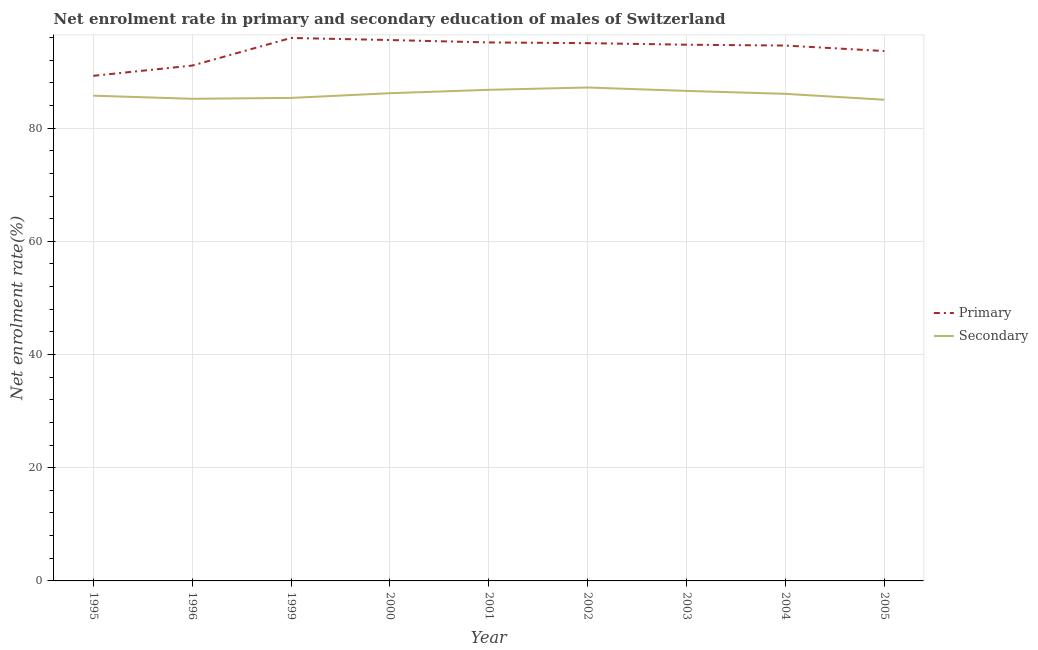What is the enrollment rate in primary education in 2004?
Keep it short and to the point. 94.58. Across all years, what is the maximum enrollment rate in primary education?
Offer a very short reply. 95.92. Across all years, what is the minimum enrollment rate in secondary education?
Ensure brevity in your answer.  85.01. In which year was the enrollment rate in primary education maximum?
Offer a very short reply. 1999. In which year was the enrollment rate in secondary education minimum?
Provide a short and direct response. 2005. What is the total enrollment rate in secondary education in the graph?
Your answer should be very brief. 773.93. What is the difference between the enrollment rate in primary education in 1996 and that in 2002?
Give a very brief answer. -3.96. What is the difference between the enrollment rate in secondary education in 2003 and the enrollment rate in primary education in 2001?
Your answer should be compact. -8.56. What is the average enrollment rate in primary education per year?
Make the answer very short. 93.86. In the year 2005, what is the difference between the enrollment rate in primary education and enrollment rate in secondary education?
Provide a succinct answer. 8.6. What is the ratio of the enrollment rate in secondary education in 1999 to that in 2000?
Your answer should be compact. 0.99. Is the enrollment rate in secondary education in 1996 less than that in 2000?
Make the answer very short. Yes. What is the difference between the highest and the second highest enrollment rate in secondary education?
Make the answer very short. 0.41. What is the difference between the highest and the lowest enrollment rate in primary education?
Your answer should be compact. 6.69. Is the enrollment rate in secondary education strictly greater than the enrollment rate in primary education over the years?
Offer a very short reply. No. Is the enrollment rate in secondary education strictly less than the enrollment rate in primary education over the years?
Offer a very short reply. Yes. Are the values on the major ticks of Y-axis written in scientific E-notation?
Provide a succinct answer. No. Does the graph contain any zero values?
Offer a very short reply. No. How many legend labels are there?
Keep it short and to the point. 2. What is the title of the graph?
Give a very brief answer. Net enrolment rate in primary and secondary education of males of Switzerland. What is the label or title of the Y-axis?
Your answer should be very brief. Net enrolment rate(%). What is the Net enrolment rate(%) in Primary in 1995?
Ensure brevity in your answer.  89.23. What is the Net enrolment rate(%) of Secondary in 1995?
Offer a terse response. 85.72. What is the Net enrolment rate(%) of Primary in 1996?
Your answer should be compact. 91.04. What is the Net enrolment rate(%) in Secondary in 1996?
Keep it short and to the point. 85.17. What is the Net enrolment rate(%) of Primary in 1999?
Keep it short and to the point. 95.92. What is the Net enrolment rate(%) in Secondary in 1999?
Provide a short and direct response. 85.33. What is the Net enrolment rate(%) in Primary in 2000?
Provide a short and direct response. 95.55. What is the Net enrolment rate(%) in Secondary in 2000?
Your answer should be compact. 86.16. What is the Net enrolment rate(%) in Primary in 2001?
Make the answer very short. 95.13. What is the Net enrolment rate(%) in Secondary in 2001?
Make the answer very short. 86.76. What is the Net enrolment rate(%) in Primary in 2002?
Give a very brief answer. 95. What is the Net enrolment rate(%) of Secondary in 2002?
Your answer should be compact. 87.17. What is the Net enrolment rate(%) in Primary in 2003?
Your answer should be compact. 94.73. What is the Net enrolment rate(%) in Secondary in 2003?
Make the answer very short. 86.57. What is the Net enrolment rate(%) in Primary in 2004?
Keep it short and to the point. 94.58. What is the Net enrolment rate(%) of Secondary in 2004?
Offer a terse response. 86.05. What is the Net enrolment rate(%) in Primary in 2005?
Keep it short and to the point. 93.61. What is the Net enrolment rate(%) in Secondary in 2005?
Your answer should be very brief. 85.01. Across all years, what is the maximum Net enrolment rate(%) in Primary?
Your answer should be very brief. 95.92. Across all years, what is the maximum Net enrolment rate(%) in Secondary?
Your response must be concise. 87.17. Across all years, what is the minimum Net enrolment rate(%) in Primary?
Give a very brief answer. 89.23. Across all years, what is the minimum Net enrolment rate(%) of Secondary?
Offer a very short reply. 85.01. What is the total Net enrolment rate(%) of Primary in the graph?
Give a very brief answer. 844.78. What is the total Net enrolment rate(%) in Secondary in the graph?
Keep it short and to the point. 773.93. What is the difference between the Net enrolment rate(%) of Primary in 1995 and that in 1996?
Offer a terse response. -1.81. What is the difference between the Net enrolment rate(%) of Secondary in 1995 and that in 1996?
Give a very brief answer. 0.55. What is the difference between the Net enrolment rate(%) of Primary in 1995 and that in 1999?
Your response must be concise. -6.69. What is the difference between the Net enrolment rate(%) in Secondary in 1995 and that in 1999?
Give a very brief answer. 0.4. What is the difference between the Net enrolment rate(%) of Primary in 1995 and that in 2000?
Keep it short and to the point. -6.32. What is the difference between the Net enrolment rate(%) in Secondary in 1995 and that in 2000?
Keep it short and to the point. -0.43. What is the difference between the Net enrolment rate(%) in Primary in 1995 and that in 2001?
Offer a terse response. -5.9. What is the difference between the Net enrolment rate(%) in Secondary in 1995 and that in 2001?
Offer a terse response. -1.04. What is the difference between the Net enrolment rate(%) in Primary in 1995 and that in 2002?
Provide a succinct answer. -5.77. What is the difference between the Net enrolment rate(%) in Secondary in 1995 and that in 2002?
Ensure brevity in your answer.  -1.44. What is the difference between the Net enrolment rate(%) in Primary in 1995 and that in 2003?
Offer a terse response. -5.5. What is the difference between the Net enrolment rate(%) in Secondary in 1995 and that in 2003?
Provide a short and direct response. -0.84. What is the difference between the Net enrolment rate(%) of Primary in 1995 and that in 2004?
Your answer should be very brief. -5.35. What is the difference between the Net enrolment rate(%) of Secondary in 1995 and that in 2004?
Your answer should be compact. -0.32. What is the difference between the Net enrolment rate(%) of Primary in 1995 and that in 2005?
Provide a succinct answer. -4.38. What is the difference between the Net enrolment rate(%) of Secondary in 1995 and that in 2005?
Ensure brevity in your answer.  0.72. What is the difference between the Net enrolment rate(%) of Primary in 1996 and that in 1999?
Provide a succinct answer. -4.88. What is the difference between the Net enrolment rate(%) of Secondary in 1996 and that in 1999?
Make the answer very short. -0.16. What is the difference between the Net enrolment rate(%) of Primary in 1996 and that in 2000?
Give a very brief answer. -4.51. What is the difference between the Net enrolment rate(%) of Secondary in 1996 and that in 2000?
Make the answer very short. -0.98. What is the difference between the Net enrolment rate(%) in Primary in 1996 and that in 2001?
Provide a succinct answer. -4.09. What is the difference between the Net enrolment rate(%) in Secondary in 1996 and that in 2001?
Provide a short and direct response. -1.59. What is the difference between the Net enrolment rate(%) in Primary in 1996 and that in 2002?
Provide a short and direct response. -3.96. What is the difference between the Net enrolment rate(%) of Secondary in 1996 and that in 2002?
Offer a very short reply. -1.99. What is the difference between the Net enrolment rate(%) in Primary in 1996 and that in 2003?
Keep it short and to the point. -3.69. What is the difference between the Net enrolment rate(%) of Secondary in 1996 and that in 2003?
Ensure brevity in your answer.  -1.39. What is the difference between the Net enrolment rate(%) of Primary in 1996 and that in 2004?
Give a very brief answer. -3.54. What is the difference between the Net enrolment rate(%) of Secondary in 1996 and that in 2004?
Your answer should be compact. -0.88. What is the difference between the Net enrolment rate(%) in Primary in 1996 and that in 2005?
Give a very brief answer. -2.57. What is the difference between the Net enrolment rate(%) in Secondary in 1996 and that in 2005?
Your response must be concise. 0.17. What is the difference between the Net enrolment rate(%) of Primary in 1999 and that in 2000?
Ensure brevity in your answer.  0.37. What is the difference between the Net enrolment rate(%) in Secondary in 1999 and that in 2000?
Your response must be concise. -0.83. What is the difference between the Net enrolment rate(%) of Primary in 1999 and that in 2001?
Your response must be concise. 0.79. What is the difference between the Net enrolment rate(%) of Secondary in 1999 and that in 2001?
Your response must be concise. -1.43. What is the difference between the Net enrolment rate(%) in Primary in 1999 and that in 2002?
Your answer should be compact. 0.92. What is the difference between the Net enrolment rate(%) in Secondary in 1999 and that in 2002?
Ensure brevity in your answer.  -1.84. What is the difference between the Net enrolment rate(%) in Primary in 1999 and that in 2003?
Provide a short and direct response. 1.19. What is the difference between the Net enrolment rate(%) in Secondary in 1999 and that in 2003?
Provide a succinct answer. -1.24. What is the difference between the Net enrolment rate(%) in Primary in 1999 and that in 2004?
Offer a terse response. 1.34. What is the difference between the Net enrolment rate(%) in Secondary in 1999 and that in 2004?
Offer a very short reply. -0.72. What is the difference between the Net enrolment rate(%) in Primary in 1999 and that in 2005?
Your answer should be very brief. 2.31. What is the difference between the Net enrolment rate(%) in Secondary in 1999 and that in 2005?
Keep it short and to the point. 0.32. What is the difference between the Net enrolment rate(%) of Primary in 2000 and that in 2001?
Your answer should be compact. 0.42. What is the difference between the Net enrolment rate(%) of Secondary in 2000 and that in 2001?
Give a very brief answer. -0.6. What is the difference between the Net enrolment rate(%) in Primary in 2000 and that in 2002?
Provide a short and direct response. 0.55. What is the difference between the Net enrolment rate(%) in Secondary in 2000 and that in 2002?
Offer a very short reply. -1.01. What is the difference between the Net enrolment rate(%) of Primary in 2000 and that in 2003?
Keep it short and to the point. 0.82. What is the difference between the Net enrolment rate(%) in Secondary in 2000 and that in 2003?
Provide a succinct answer. -0.41. What is the difference between the Net enrolment rate(%) in Primary in 2000 and that in 2004?
Give a very brief answer. 0.97. What is the difference between the Net enrolment rate(%) of Secondary in 2000 and that in 2004?
Ensure brevity in your answer.  0.11. What is the difference between the Net enrolment rate(%) in Primary in 2000 and that in 2005?
Make the answer very short. 1.94. What is the difference between the Net enrolment rate(%) in Secondary in 2000 and that in 2005?
Make the answer very short. 1.15. What is the difference between the Net enrolment rate(%) of Primary in 2001 and that in 2002?
Make the answer very short. 0.13. What is the difference between the Net enrolment rate(%) of Secondary in 2001 and that in 2002?
Provide a short and direct response. -0.41. What is the difference between the Net enrolment rate(%) of Primary in 2001 and that in 2003?
Offer a very short reply. 0.4. What is the difference between the Net enrolment rate(%) of Secondary in 2001 and that in 2003?
Ensure brevity in your answer.  0.19. What is the difference between the Net enrolment rate(%) in Primary in 2001 and that in 2004?
Your response must be concise. 0.55. What is the difference between the Net enrolment rate(%) of Secondary in 2001 and that in 2004?
Make the answer very short. 0.71. What is the difference between the Net enrolment rate(%) of Primary in 2001 and that in 2005?
Give a very brief answer. 1.52. What is the difference between the Net enrolment rate(%) in Secondary in 2001 and that in 2005?
Provide a short and direct response. 1.75. What is the difference between the Net enrolment rate(%) in Primary in 2002 and that in 2003?
Offer a terse response. 0.27. What is the difference between the Net enrolment rate(%) of Secondary in 2002 and that in 2003?
Provide a succinct answer. 0.6. What is the difference between the Net enrolment rate(%) in Primary in 2002 and that in 2004?
Give a very brief answer. 0.42. What is the difference between the Net enrolment rate(%) in Secondary in 2002 and that in 2004?
Your answer should be compact. 1.12. What is the difference between the Net enrolment rate(%) of Primary in 2002 and that in 2005?
Your answer should be very brief. 1.4. What is the difference between the Net enrolment rate(%) in Secondary in 2002 and that in 2005?
Your answer should be compact. 2.16. What is the difference between the Net enrolment rate(%) in Primary in 2003 and that in 2004?
Your answer should be very brief. 0.15. What is the difference between the Net enrolment rate(%) of Secondary in 2003 and that in 2004?
Offer a terse response. 0.52. What is the difference between the Net enrolment rate(%) in Primary in 2003 and that in 2005?
Your answer should be compact. 1.12. What is the difference between the Net enrolment rate(%) in Secondary in 2003 and that in 2005?
Your answer should be very brief. 1.56. What is the difference between the Net enrolment rate(%) in Primary in 2004 and that in 2005?
Your answer should be very brief. 0.97. What is the difference between the Net enrolment rate(%) in Secondary in 2004 and that in 2005?
Make the answer very short. 1.04. What is the difference between the Net enrolment rate(%) in Primary in 1995 and the Net enrolment rate(%) in Secondary in 1996?
Make the answer very short. 4.06. What is the difference between the Net enrolment rate(%) in Primary in 1995 and the Net enrolment rate(%) in Secondary in 1999?
Offer a very short reply. 3.9. What is the difference between the Net enrolment rate(%) of Primary in 1995 and the Net enrolment rate(%) of Secondary in 2000?
Your answer should be compact. 3.07. What is the difference between the Net enrolment rate(%) in Primary in 1995 and the Net enrolment rate(%) in Secondary in 2001?
Your response must be concise. 2.47. What is the difference between the Net enrolment rate(%) of Primary in 1995 and the Net enrolment rate(%) of Secondary in 2002?
Your answer should be compact. 2.06. What is the difference between the Net enrolment rate(%) in Primary in 1995 and the Net enrolment rate(%) in Secondary in 2003?
Keep it short and to the point. 2.66. What is the difference between the Net enrolment rate(%) of Primary in 1995 and the Net enrolment rate(%) of Secondary in 2004?
Your answer should be compact. 3.18. What is the difference between the Net enrolment rate(%) in Primary in 1995 and the Net enrolment rate(%) in Secondary in 2005?
Your response must be concise. 4.23. What is the difference between the Net enrolment rate(%) in Primary in 1996 and the Net enrolment rate(%) in Secondary in 1999?
Your answer should be very brief. 5.71. What is the difference between the Net enrolment rate(%) in Primary in 1996 and the Net enrolment rate(%) in Secondary in 2000?
Your response must be concise. 4.88. What is the difference between the Net enrolment rate(%) of Primary in 1996 and the Net enrolment rate(%) of Secondary in 2001?
Provide a short and direct response. 4.28. What is the difference between the Net enrolment rate(%) in Primary in 1996 and the Net enrolment rate(%) in Secondary in 2002?
Ensure brevity in your answer.  3.87. What is the difference between the Net enrolment rate(%) of Primary in 1996 and the Net enrolment rate(%) of Secondary in 2003?
Your response must be concise. 4.47. What is the difference between the Net enrolment rate(%) in Primary in 1996 and the Net enrolment rate(%) in Secondary in 2004?
Provide a short and direct response. 4.99. What is the difference between the Net enrolment rate(%) in Primary in 1996 and the Net enrolment rate(%) in Secondary in 2005?
Ensure brevity in your answer.  6.03. What is the difference between the Net enrolment rate(%) of Primary in 1999 and the Net enrolment rate(%) of Secondary in 2000?
Offer a terse response. 9.76. What is the difference between the Net enrolment rate(%) in Primary in 1999 and the Net enrolment rate(%) in Secondary in 2001?
Provide a succinct answer. 9.16. What is the difference between the Net enrolment rate(%) in Primary in 1999 and the Net enrolment rate(%) in Secondary in 2002?
Provide a short and direct response. 8.75. What is the difference between the Net enrolment rate(%) in Primary in 1999 and the Net enrolment rate(%) in Secondary in 2003?
Your response must be concise. 9.35. What is the difference between the Net enrolment rate(%) of Primary in 1999 and the Net enrolment rate(%) of Secondary in 2004?
Offer a very short reply. 9.87. What is the difference between the Net enrolment rate(%) of Primary in 1999 and the Net enrolment rate(%) of Secondary in 2005?
Offer a terse response. 10.91. What is the difference between the Net enrolment rate(%) in Primary in 2000 and the Net enrolment rate(%) in Secondary in 2001?
Give a very brief answer. 8.79. What is the difference between the Net enrolment rate(%) of Primary in 2000 and the Net enrolment rate(%) of Secondary in 2002?
Offer a very short reply. 8.38. What is the difference between the Net enrolment rate(%) of Primary in 2000 and the Net enrolment rate(%) of Secondary in 2003?
Offer a very short reply. 8.98. What is the difference between the Net enrolment rate(%) in Primary in 2000 and the Net enrolment rate(%) in Secondary in 2004?
Ensure brevity in your answer.  9.5. What is the difference between the Net enrolment rate(%) in Primary in 2000 and the Net enrolment rate(%) in Secondary in 2005?
Your response must be concise. 10.55. What is the difference between the Net enrolment rate(%) in Primary in 2001 and the Net enrolment rate(%) in Secondary in 2002?
Your answer should be very brief. 7.96. What is the difference between the Net enrolment rate(%) of Primary in 2001 and the Net enrolment rate(%) of Secondary in 2003?
Ensure brevity in your answer.  8.56. What is the difference between the Net enrolment rate(%) in Primary in 2001 and the Net enrolment rate(%) in Secondary in 2004?
Offer a terse response. 9.08. What is the difference between the Net enrolment rate(%) of Primary in 2001 and the Net enrolment rate(%) of Secondary in 2005?
Offer a very short reply. 10.12. What is the difference between the Net enrolment rate(%) of Primary in 2002 and the Net enrolment rate(%) of Secondary in 2003?
Your answer should be compact. 8.44. What is the difference between the Net enrolment rate(%) of Primary in 2002 and the Net enrolment rate(%) of Secondary in 2004?
Offer a very short reply. 8.95. What is the difference between the Net enrolment rate(%) in Primary in 2002 and the Net enrolment rate(%) in Secondary in 2005?
Provide a short and direct response. 10. What is the difference between the Net enrolment rate(%) in Primary in 2003 and the Net enrolment rate(%) in Secondary in 2004?
Your answer should be compact. 8.68. What is the difference between the Net enrolment rate(%) of Primary in 2003 and the Net enrolment rate(%) of Secondary in 2005?
Give a very brief answer. 9.72. What is the difference between the Net enrolment rate(%) of Primary in 2004 and the Net enrolment rate(%) of Secondary in 2005?
Make the answer very short. 9.57. What is the average Net enrolment rate(%) in Primary per year?
Offer a very short reply. 93.86. What is the average Net enrolment rate(%) of Secondary per year?
Provide a succinct answer. 85.99. In the year 1995, what is the difference between the Net enrolment rate(%) of Primary and Net enrolment rate(%) of Secondary?
Provide a short and direct response. 3.51. In the year 1996, what is the difference between the Net enrolment rate(%) of Primary and Net enrolment rate(%) of Secondary?
Your answer should be very brief. 5.87. In the year 1999, what is the difference between the Net enrolment rate(%) in Primary and Net enrolment rate(%) in Secondary?
Ensure brevity in your answer.  10.59. In the year 2000, what is the difference between the Net enrolment rate(%) of Primary and Net enrolment rate(%) of Secondary?
Provide a succinct answer. 9.39. In the year 2001, what is the difference between the Net enrolment rate(%) in Primary and Net enrolment rate(%) in Secondary?
Provide a short and direct response. 8.37. In the year 2002, what is the difference between the Net enrolment rate(%) of Primary and Net enrolment rate(%) of Secondary?
Your response must be concise. 7.84. In the year 2003, what is the difference between the Net enrolment rate(%) of Primary and Net enrolment rate(%) of Secondary?
Ensure brevity in your answer.  8.16. In the year 2004, what is the difference between the Net enrolment rate(%) of Primary and Net enrolment rate(%) of Secondary?
Your answer should be very brief. 8.53. In the year 2005, what is the difference between the Net enrolment rate(%) of Primary and Net enrolment rate(%) of Secondary?
Offer a very short reply. 8.6. What is the ratio of the Net enrolment rate(%) in Primary in 1995 to that in 1996?
Give a very brief answer. 0.98. What is the ratio of the Net enrolment rate(%) of Secondary in 1995 to that in 1996?
Offer a terse response. 1.01. What is the ratio of the Net enrolment rate(%) of Primary in 1995 to that in 1999?
Keep it short and to the point. 0.93. What is the ratio of the Net enrolment rate(%) of Secondary in 1995 to that in 1999?
Provide a short and direct response. 1. What is the ratio of the Net enrolment rate(%) in Primary in 1995 to that in 2000?
Make the answer very short. 0.93. What is the ratio of the Net enrolment rate(%) in Primary in 1995 to that in 2001?
Give a very brief answer. 0.94. What is the ratio of the Net enrolment rate(%) in Secondary in 1995 to that in 2001?
Provide a succinct answer. 0.99. What is the ratio of the Net enrolment rate(%) of Primary in 1995 to that in 2002?
Provide a succinct answer. 0.94. What is the ratio of the Net enrolment rate(%) in Secondary in 1995 to that in 2002?
Offer a very short reply. 0.98. What is the ratio of the Net enrolment rate(%) of Primary in 1995 to that in 2003?
Provide a short and direct response. 0.94. What is the ratio of the Net enrolment rate(%) of Secondary in 1995 to that in 2003?
Your answer should be compact. 0.99. What is the ratio of the Net enrolment rate(%) of Primary in 1995 to that in 2004?
Your answer should be compact. 0.94. What is the ratio of the Net enrolment rate(%) of Secondary in 1995 to that in 2004?
Ensure brevity in your answer.  1. What is the ratio of the Net enrolment rate(%) in Primary in 1995 to that in 2005?
Your answer should be compact. 0.95. What is the ratio of the Net enrolment rate(%) of Secondary in 1995 to that in 2005?
Ensure brevity in your answer.  1.01. What is the ratio of the Net enrolment rate(%) in Primary in 1996 to that in 1999?
Your answer should be compact. 0.95. What is the ratio of the Net enrolment rate(%) in Secondary in 1996 to that in 1999?
Offer a very short reply. 1. What is the ratio of the Net enrolment rate(%) of Primary in 1996 to that in 2000?
Give a very brief answer. 0.95. What is the ratio of the Net enrolment rate(%) in Primary in 1996 to that in 2001?
Give a very brief answer. 0.96. What is the ratio of the Net enrolment rate(%) of Secondary in 1996 to that in 2001?
Offer a very short reply. 0.98. What is the ratio of the Net enrolment rate(%) in Primary in 1996 to that in 2002?
Provide a short and direct response. 0.96. What is the ratio of the Net enrolment rate(%) of Secondary in 1996 to that in 2002?
Offer a terse response. 0.98. What is the ratio of the Net enrolment rate(%) of Primary in 1996 to that in 2003?
Provide a succinct answer. 0.96. What is the ratio of the Net enrolment rate(%) in Secondary in 1996 to that in 2003?
Provide a succinct answer. 0.98. What is the ratio of the Net enrolment rate(%) of Primary in 1996 to that in 2004?
Keep it short and to the point. 0.96. What is the ratio of the Net enrolment rate(%) in Secondary in 1996 to that in 2004?
Ensure brevity in your answer.  0.99. What is the ratio of the Net enrolment rate(%) of Primary in 1996 to that in 2005?
Provide a short and direct response. 0.97. What is the ratio of the Net enrolment rate(%) of Secondary in 1996 to that in 2005?
Your answer should be very brief. 1. What is the ratio of the Net enrolment rate(%) in Primary in 1999 to that in 2000?
Offer a very short reply. 1. What is the ratio of the Net enrolment rate(%) in Secondary in 1999 to that in 2000?
Ensure brevity in your answer.  0.99. What is the ratio of the Net enrolment rate(%) in Primary in 1999 to that in 2001?
Provide a short and direct response. 1.01. What is the ratio of the Net enrolment rate(%) of Secondary in 1999 to that in 2001?
Provide a short and direct response. 0.98. What is the ratio of the Net enrolment rate(%) in Primary in 1999 to that in 2002?
Provide a succinct answer. 1.01. What is the ratio of the Net enrolment rate(%) in Secondary in 1999 to that in 2002?
Your answer should be compact. 0.98. What is the ratio of the Net enrolment rate(%) in Primary in 1999 to that in 2003?
Your answer should be compact. 1.01. What is the ratio of the Net enrolment rate(%) in Secondary in 1999 to that in 2003?
Offer a very short reply. 0.99. What is the ratio of the Net enrolment rate(%) in Primary in 1999 to that in 2004?
Provide a succinct answer. 1.01. What is the ratio of the Net enrolment rate(%) of Primary in 1999 to that in 2005?
Keep it short and to the point. 1.02. What is the ratio of the Net enrolment rate(%) in Primary in 2000 to that in 2001?
Provide a succinct answer. 1. What is the ratio of the Net enrolment rate(%) of Secondary in 2000 to that in 2001?
Your response must be concise. 0.99. What is the ratio of the Net enrolment rate(%) of Primary in 2000 to that in 2002?
Your answer should be compact. 1.01. What is the ratio of the Net enrolment rate(%) in Secondary in 2000 to that in 2002?
Keep it short and to the point. 0.99. What is the ratio of the Net enrolment rate(%) of Primary in 2000 to that in 2003?
Ensure brevity in your answer.  1.01. What is the ratio of the Net enrolment rate(%) in Primary in 2000 to that in 2004?
Give a very brief answer. 1.01. What is the ratio of the Net enrolment rate(%) of Secondary in 2000 to that in 2004?
Your response must be concise. 1. What is the ratio of the Net enrolment rate(%) of Primary in 2000 to that in 2005?
Provide a short and direct response. 1.02. What is the ratio of the Net enrolment rate(%) of Secondary in 2000 to that in 2005?
Ensure brevity in your answer.  1.01. What is the ratio of the Net enrolment rate(%) in Secondary in 2001 to that in 2004?
Provide a short and direct response. 1.01. What is the ratio of the Net enrolment rate(%) of Primary in 2001 to that in 2005?
Your answer should be very brief. 1.02. What is the ratio of the Net enrolment rate(%) in Secondary in 2001 to that in 2005?
Make the answer very short. 1.02. What is the ratio of the Net enrolment rate(%) of Primary in 2002 to that in 2003?
Ensure brevity in your answer.  1. What is the ratio of the Net enrolment rate(%) in Primary in 2002 to that in 2005?
Your response must be concise. 1.01. What is the ratio of the Net enrolment rate(%) of Secondary in 2002 to that in 2005?
Your answer should be very brief. 1.03. What is the ratio of the Net enrolment rate(%) of Primary in 2003 to that in 2004?
Your response must be concise. 1. What is the ratio of the Net enrolment rate(%) of Secondary in 2003 to that in 2004?
Give a very brief answer. 1.01. What is the ratio of the Net enrolment rate(%) of Primary in 2003 to that in 2005?
Ensure brevity in your answer.  1.01. What is the ratio of the Net enrolment rate(%) of Secondary in 2003 to that in 2005?
Give a very brief answer. 1.02. What is the ratio of the Net enrolment rate(%) in Primary in 2004 to that in 2005?
Give a very brief answer. 1.01. What is the ratio of the Net enrolment rate(%) in Secondary in 2004 to that in 2005?
Give a very brief answer. 1.01. What is the difference between the highest and the second highest Net enrolment rate(%) in Primary?
Give a very brief answer. 0.37. What is the difference between the highest and the second highest Net enrolment rate(%) in Secondary?
Give a very brief answer. 0.41. What is the difference between the highest and the lowest Net enrolment rate(%) of Primary?
Offer a terse response. 6.69. What is the difference between the highest and the lowest Net enrolment rate(%) of Secondary?
Make the answer very short. 2.16. 